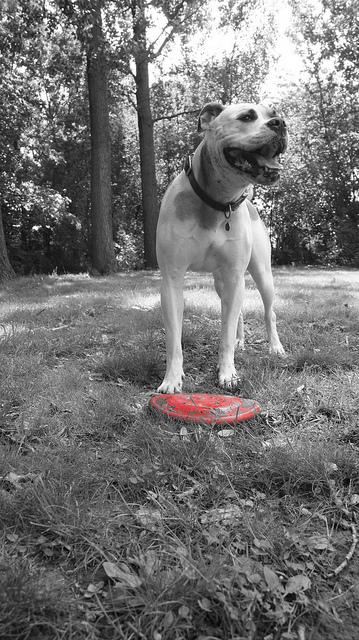What color is the dog's Frisbee?
Write a very short answer. Red. Is the dog touching the ground?
Give a very brief answer. Yes. What kind of dog is in the picture?
Answer briefly. Boxer. What is in front of the dogs paws?
Keep it brief. Frisbee. 